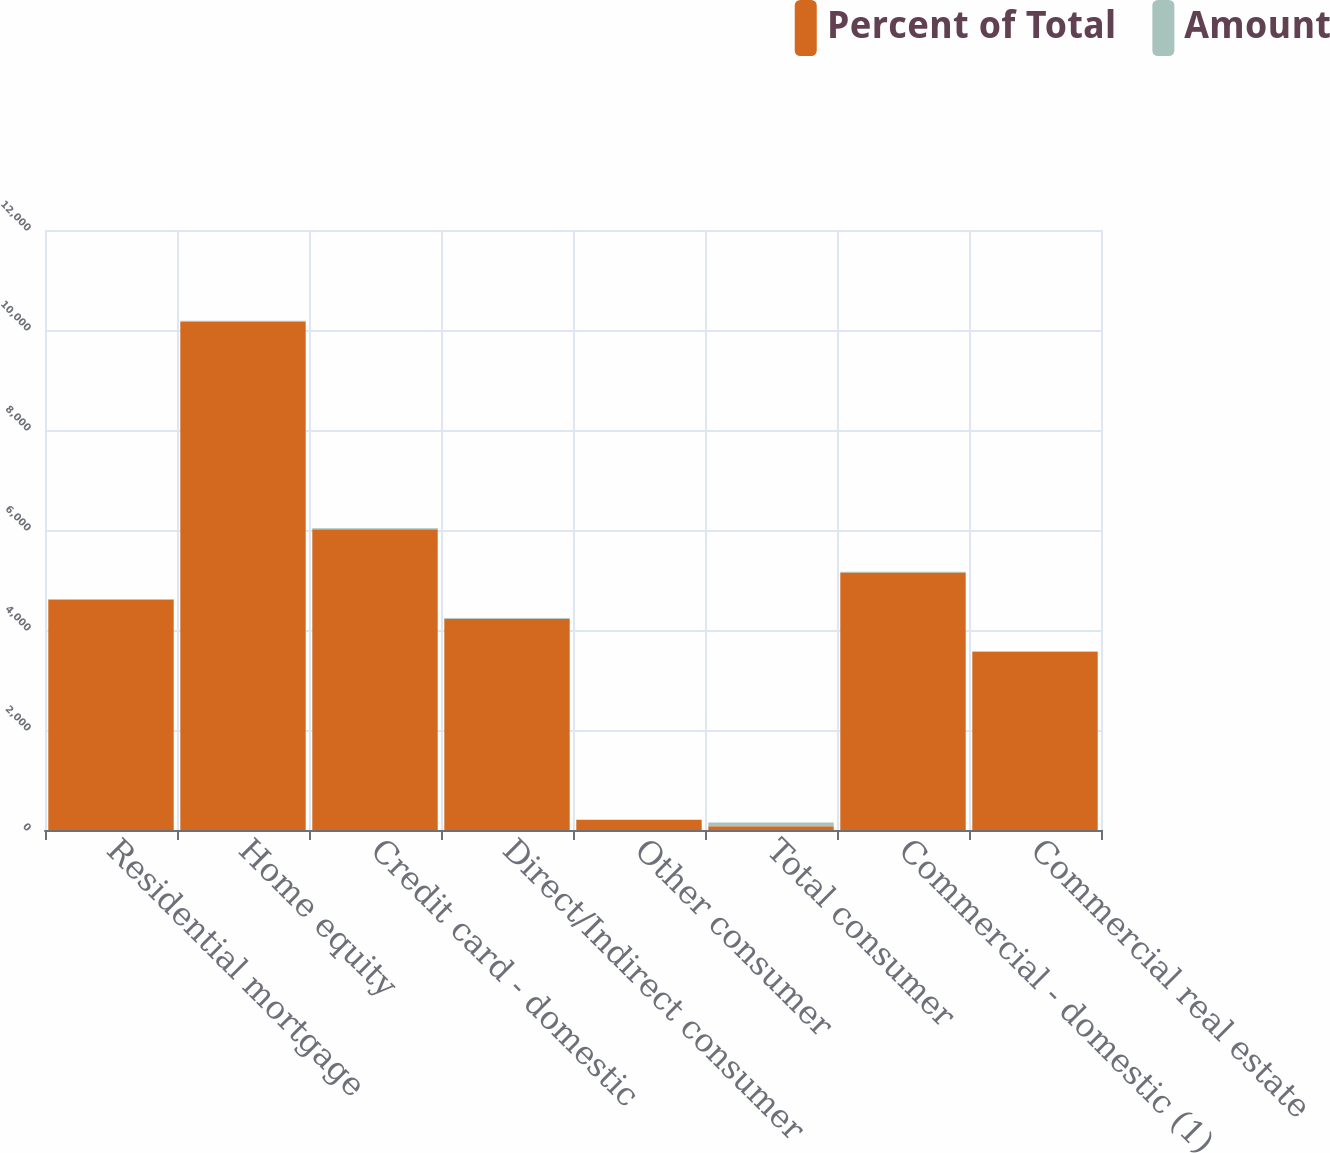<chart> <loc_0><loc_0><loc_500><loc_500><stacked_bar_chart><ecel><fcel>Residential mortgage<fcel>Home equity<fcel>Credit card - domestic<fcel>Direct/Indirect consumer<fcel>Other consumer<fcel>Total consumer<fcel>Commercial - domestic (1)<fcel>Commercial real estate<nl><fcel>Percent of Total<fcel>4607<fcel>10160<fcel>6017<fcel>4227<fcel>204<fcel>74.69<fcel>5152<fcel>3567<nl><fcel>Amount<fcel>12.38<fcel>27.31<fcel>16.18<fcel>11.36<fcel>0.55<fcel>74.69<fcel>13.85<fcel>9.59<nl></chart> 